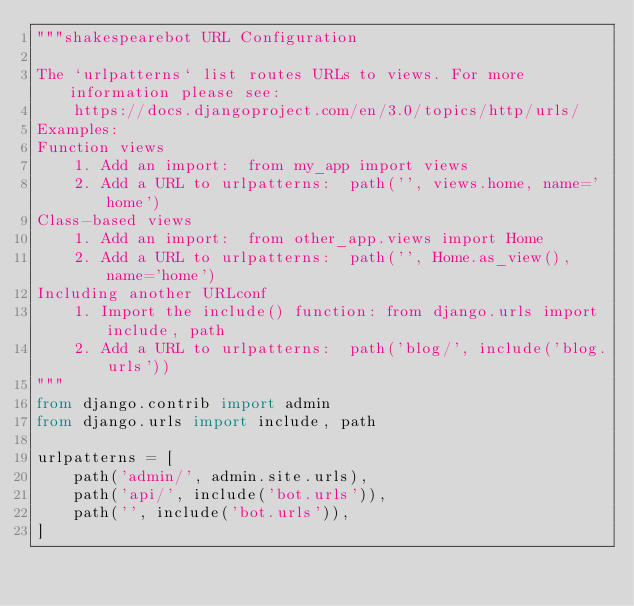Convert code to text. <code><loc_0><loc_0><loc_500><loc_500><_Python_>"""shakespearebot URL Configuration

The `urlpatterns` list routes URLs to views. For more information please see:
    https://docs.djangoproject.com/en/3.0/topics/http/urls/
Examples:
Function views
    1. Add an import:  from my_app import views
    2. Add a URL to urlpatterns:  path('', views.home, name='home')
Class-based views
    1. Add an import:  from other_app.views import Home
    2. Add a URL to urlpatterns:  path('', Home.as_view(), name='home')
Including another URLconf
    1. Import the include() function: from django.urls import include, path
    2. Add a URL to urlpatterns:  path('blog/', include('blog.urls'))
"""
from django.contrib import admin
from django.urls import include, path

urlpatterns = [
    path('admin/', admin.site.urls),
    path('api/', include('bot.urls')),
    path('', include('bot.urls')),
]
</code> 